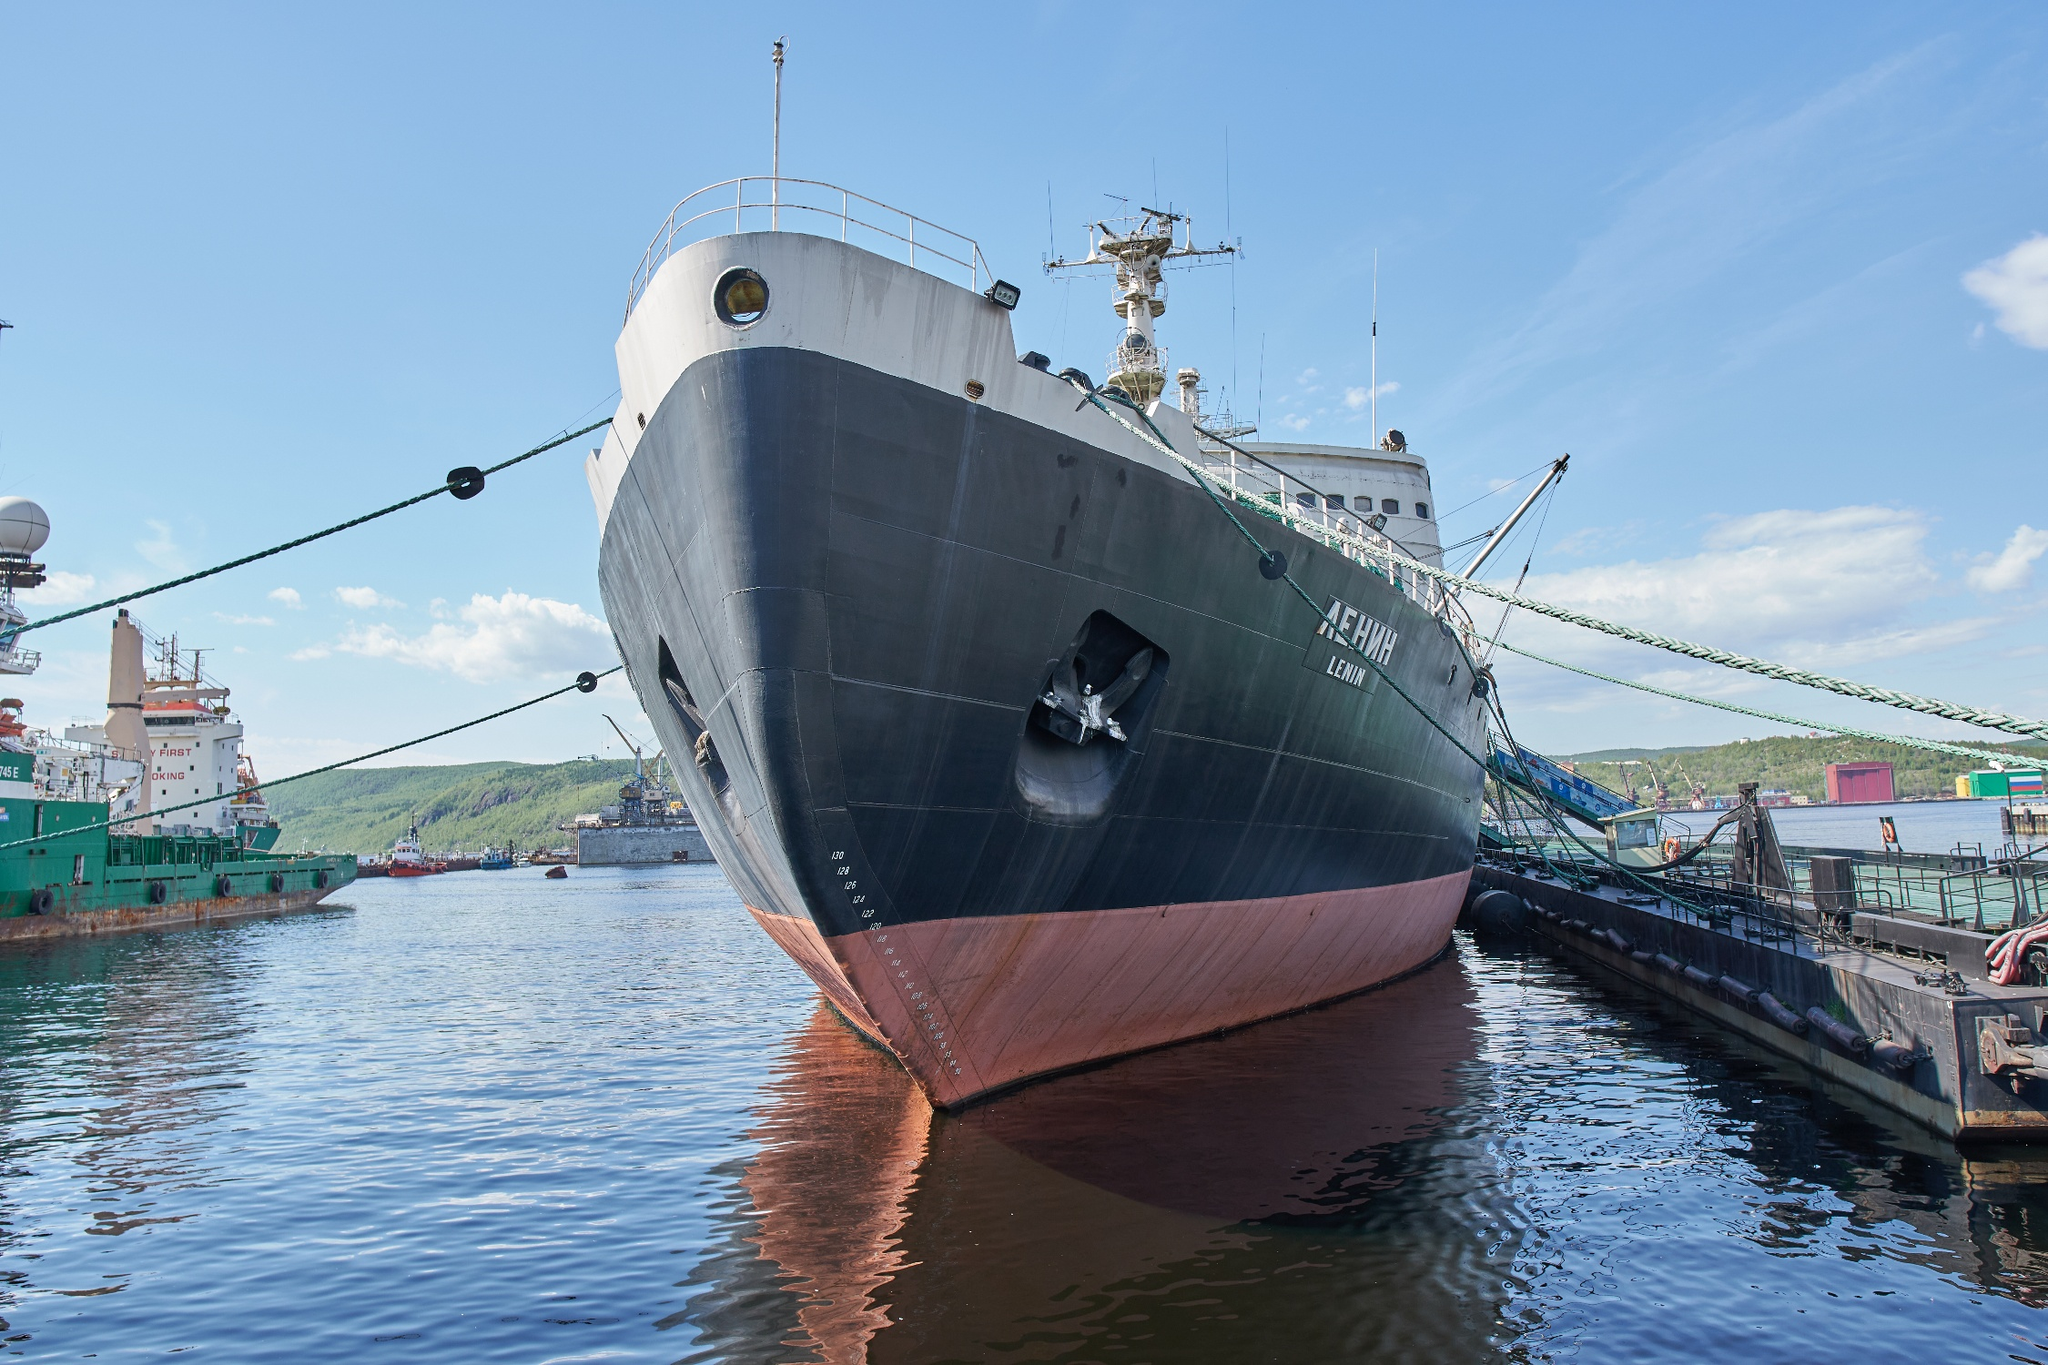Describe the following image. The photograph captures the Russian icebreaker ship named 'Lenin' docked at the port. The ship is prominently positioned from a low angle, emphasizing its massive bow painted in black with a red underside. The ship's name 'ЛЕНИН' (Lenin) is clearly visible in white letters on its side. Green ropes anchor the ship securely to the dock, and other vessels can be seen in the background. The sky is mostly clear with a few scattered clouds, and the surrounding hilly landscape presents a serene contrast to the industrial scene at the port. Overall, the image conveys a sense of calm readiness, with the ship poised for its next journey across the icy waters. 